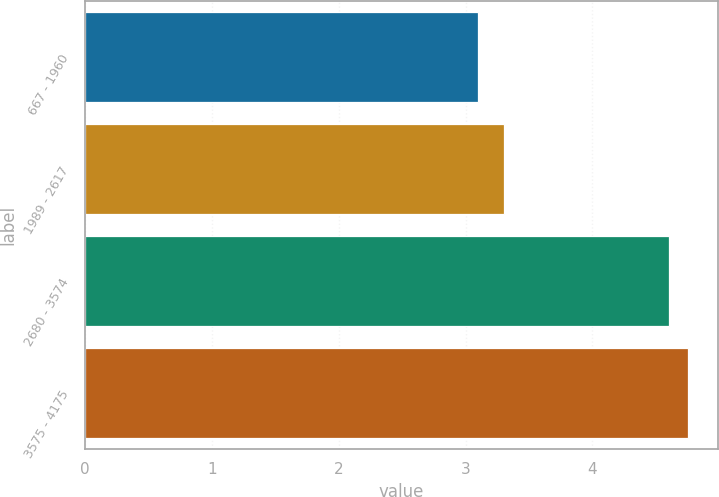Convert chart to OTSL. <chart><loc_0><loc_0><loc_500><loc_500><bar_chart><fcel>667 - 1960<fcel>1989 - 2617<fcel>2680 - 3574<fcel>3575 - 4175<nl><fcel>3.1<fcel>3.3<fcel>4.6<fcel>4.75<nl></chart> 